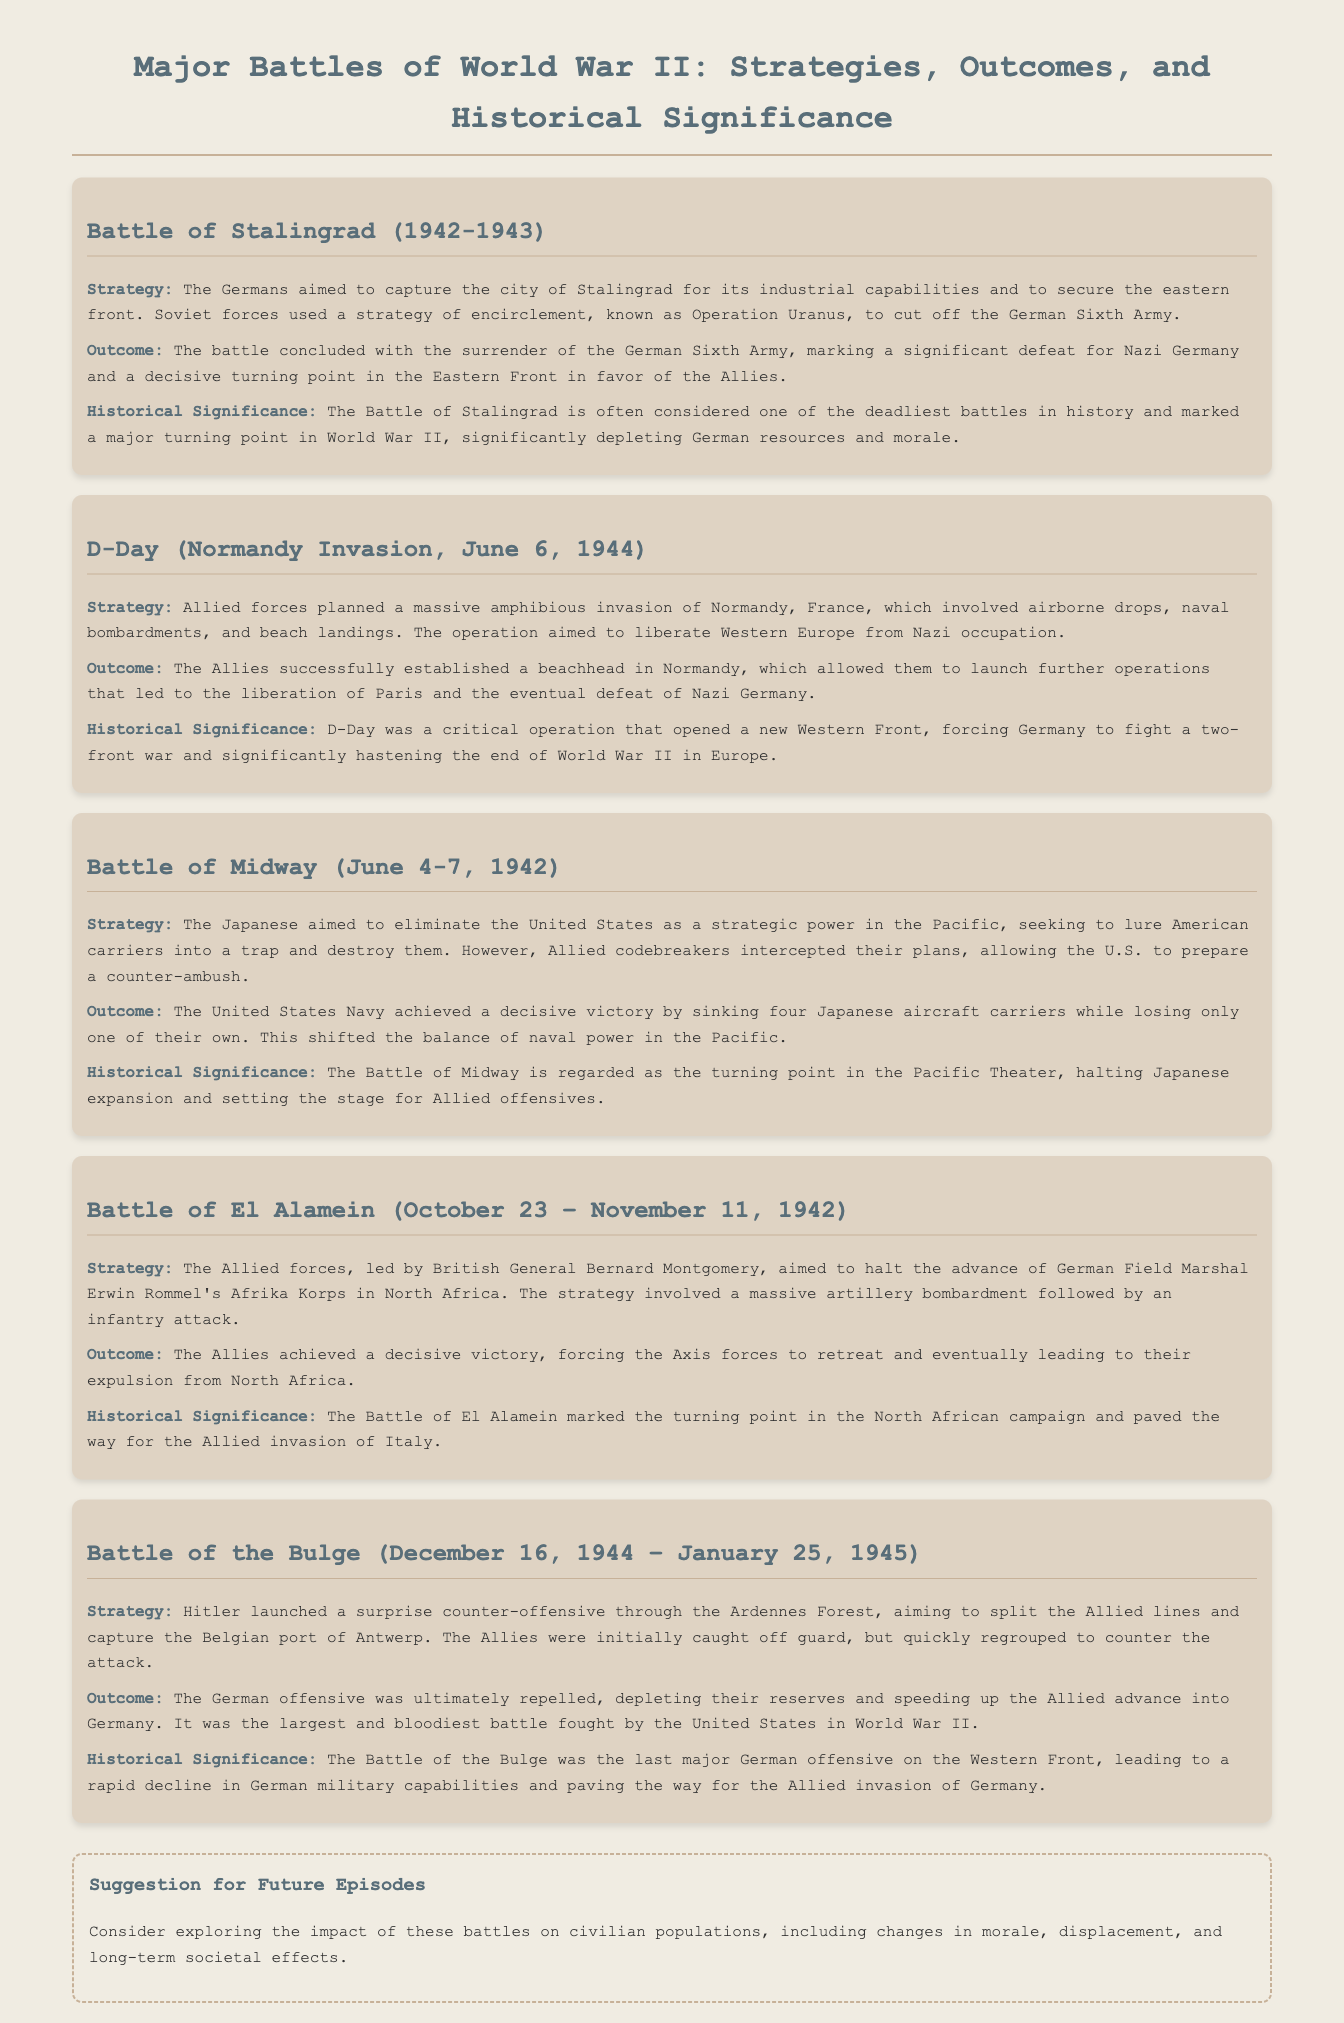What was the Battle of Stalingrad primarily aimed at? The Germans aimed to capture the city of Stalingrad for its industrial capabilities.
Answer: Industrial capabilities What was the outcome of the Battle of Midway? The United States Navy achieved a decisive victory by sinking four Japanese aircraft carriers.
Answer: Decisive victory Who led the Allied forces at the Battle of El Alamein? British General Bernard Montgomery led the Allied forces.
Answer: Bernard Montgomery What date did D-Day occur? D-Day occurred on June 6, 1944.
Answer: June 6, 1944 What was the historical significance of the Battle of the Bulge? It was the last major German offensive on the Western Front.
Answer: Last major German offensive How did the Soviet forces counter the German Army in the Battle of Stalingrad? Soviet forces used a strategy of encirclement, known as Operation Uranus.
Answer: Operation Uranus What was the primary strategy of the Japanese in the Battle of Midway? The Japanese aimed to eliminate the United States as a strategic power in the Pacific.
Answer: Eliminate the United States What major geographical feature was significant in the Battle of the Bulge? The Ardennes Forest was significant in the battle.
Answer: Ardennes Forest What was a suggestion for future episodes mentioned in the document? Consider exploring the impact of these battles on civilian populations.
Answer: Impact on civilian populations 